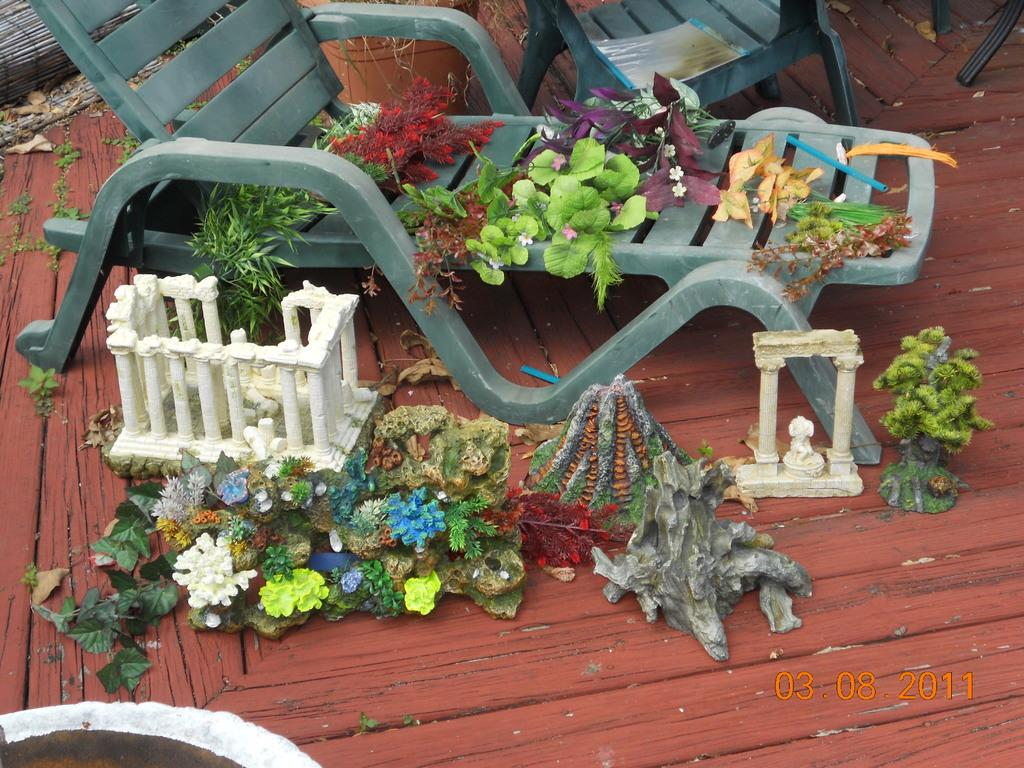What is on the chair in the image? There are objects on the chair in the image. What is on the wooden floor in the image? There are objects on the wooden floor in the image. Is there a scarf being stretched out on the chair in the image? There is no scarf present in the image, and therefore it cannot be stretched out on the chair. 